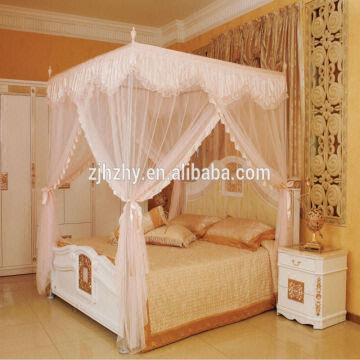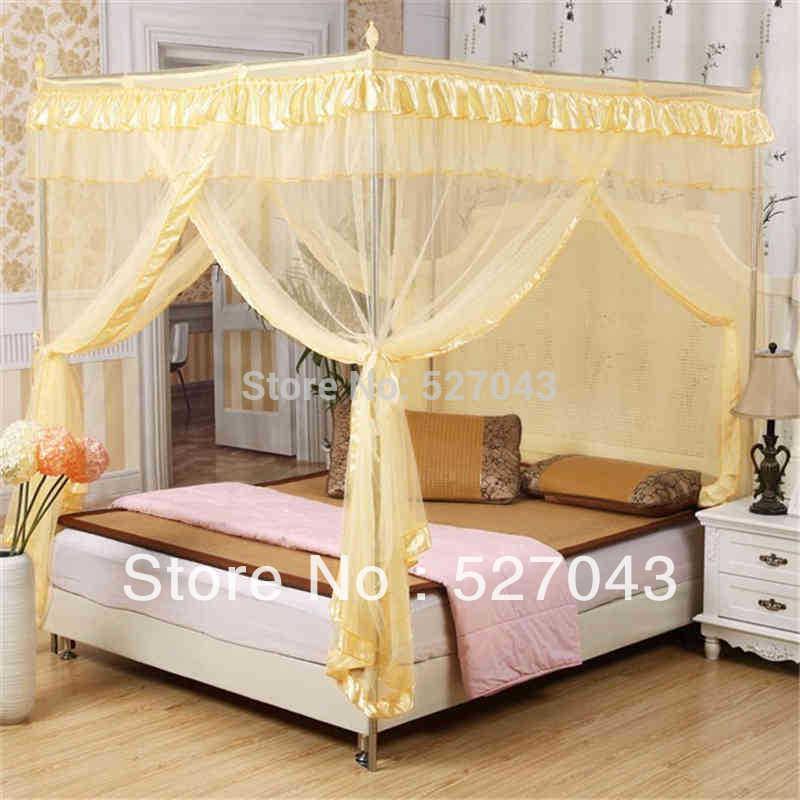The first image is the image on the left, the second image is the image on the right. For the images shown, is this caption "The canopy bed in the left image is by a window showing daylight outside." true? Answer yes or no. No. 